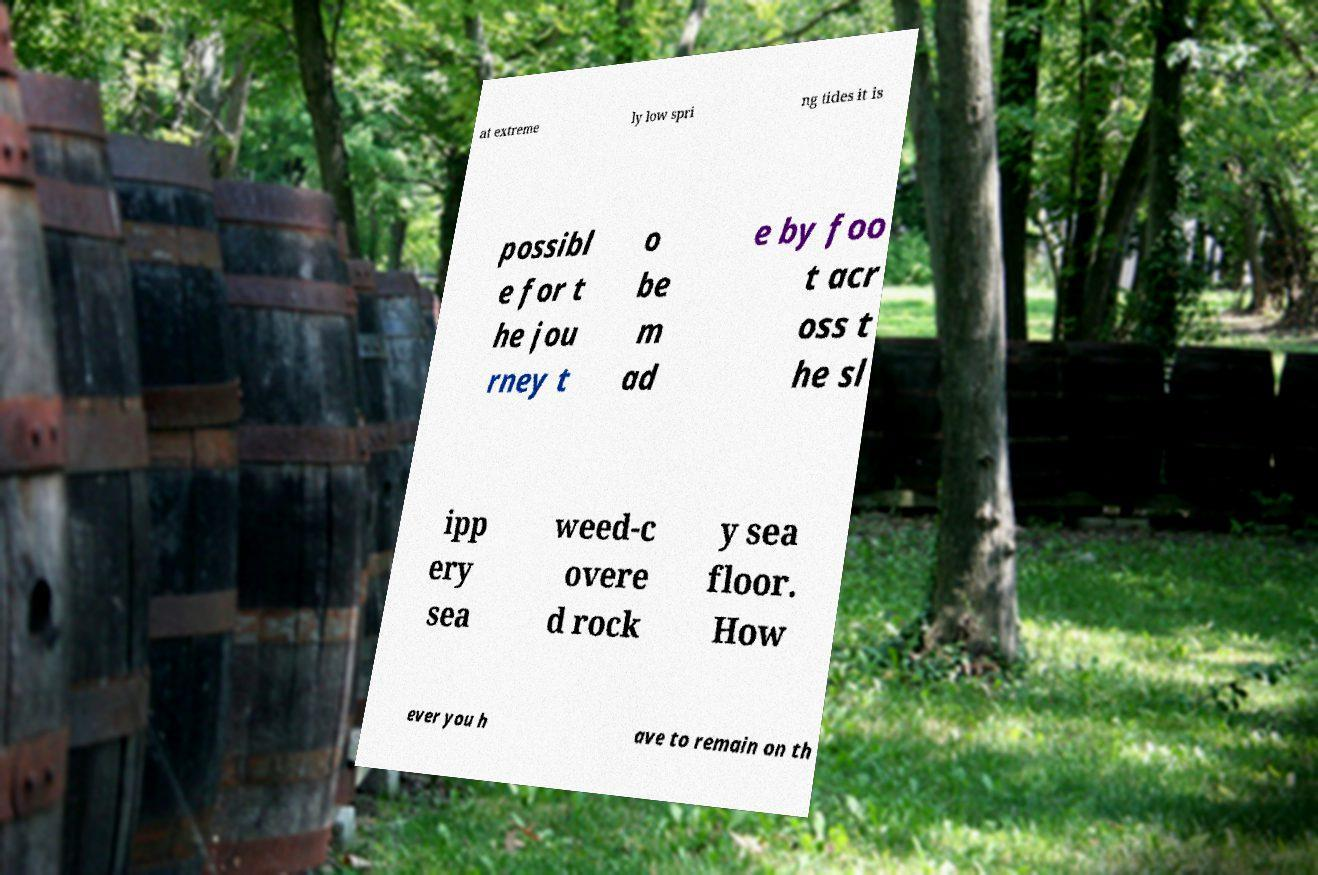For documentation purposes, I need the text within this image transcribed. Could you provide that? at extreme ly low spri ng tides it is possibl e for t he jou rney t o be m ad e by foo t acr oss t he sl ipp ery sea weed-c overe d rock y sea floor. How ever you h ave to remain on th 